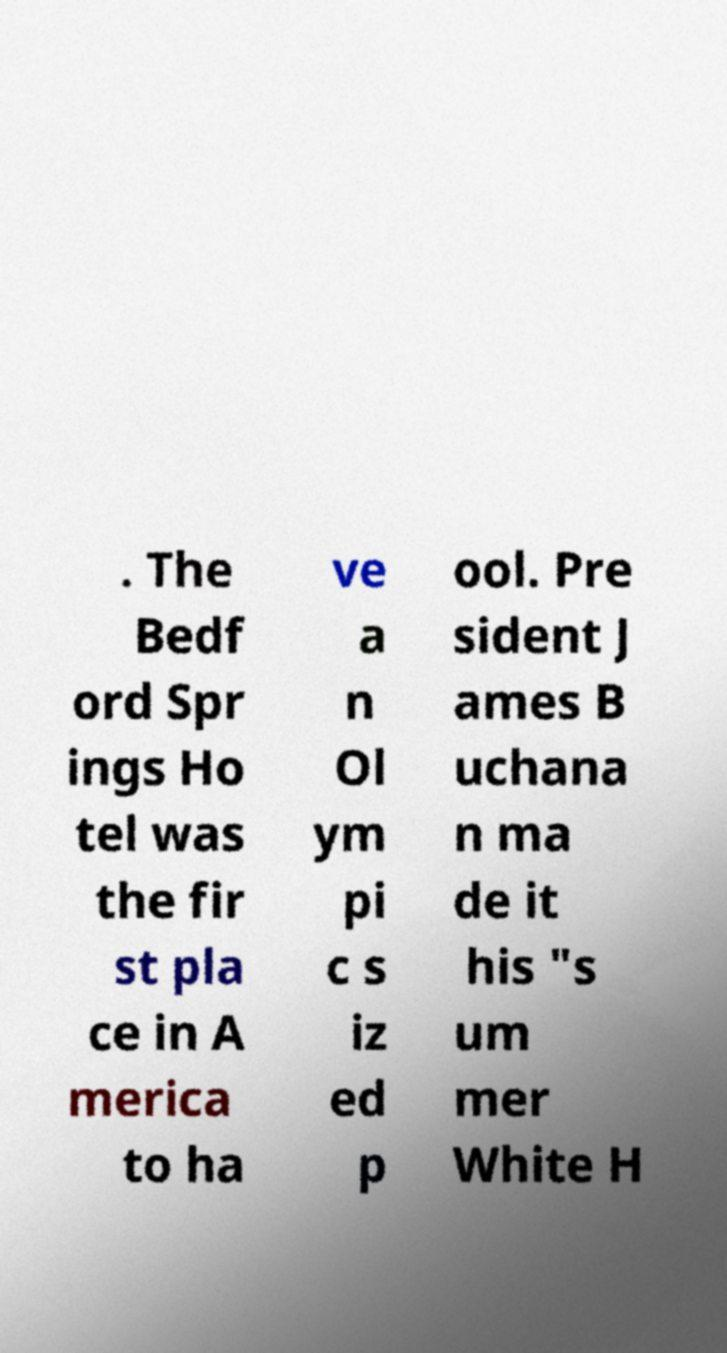There's text embedded in this image that I need extracted. Can you transcribe it verbatim? . The Bedf ord Spr ings Ho tel was the fir st pla ce in A merica to ha ve a n Ol ym pi c s iz ed p ool. Pre sident J ames B uchana n ma de it his "s um mer White H 